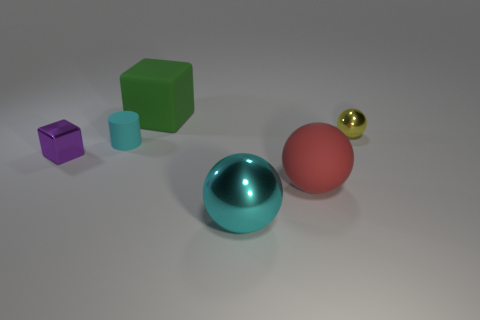Are there fewer tiny brown metal spheres than small cyan matte things?
Your response must be concise. Yes. What is the material of the cyan thing that is to the left of the cyan metal thing?
Give a very brief answer. Rubber. What material is the green thing that is the same size as the cyan metal thing?
Make the answer very short. Rubber. There is a block behind the shiny sphere that is behind the large rubber object in front of the tiny ball; what is its material?
Make the answer very short. Rubber. Does the shiny sphere that is to the right of the matte ball have the same size as the big cube?
Ensure brevity in your answer.  No. Is the number of blue metal cubes greater than the number of big matte things?
Provide a succinct answer. No. What number of small objects are either shiny cubes or cyan rubber cylinders?
Your answer should be very brief. 2. How many other things are there of the same color as the large cube?
Offer a terse response. 0. How many large blocks have the same material as the cylinder?
Provide a succinct answer. 1. Does the small metallic object on the left side of the small yellow object have the same color as the tiny ball?
Make the answer very short. No. 